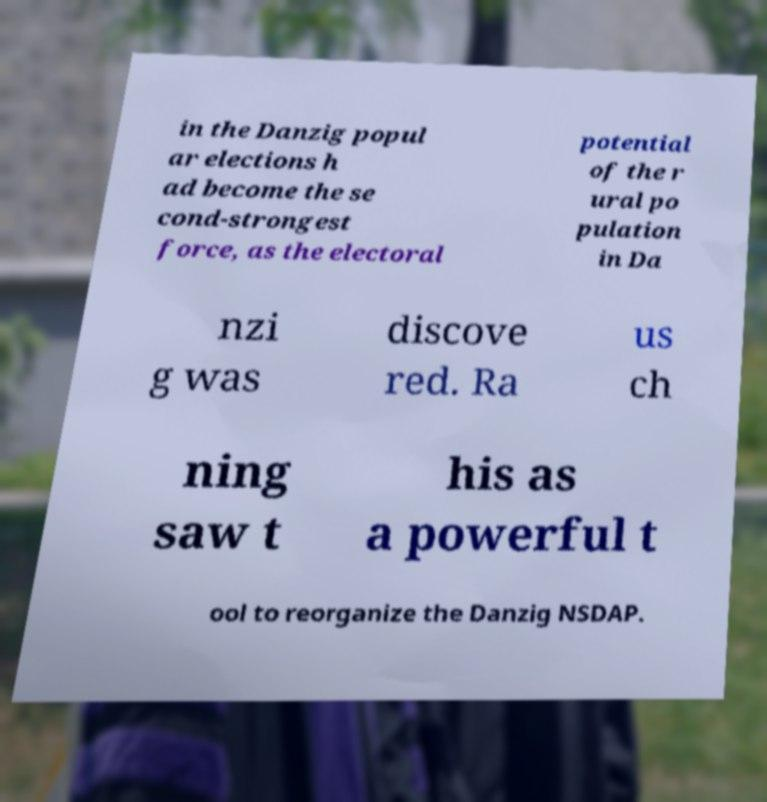Please read and relay the text visible in this image. What does it say? in the Danzig popul ar elections h ad become the se cond-strongest force, as the electoral potential of the r ural po pulation in Da nzi g was discove red. Ra us ch ning saw t his as a powerful t ool to reorganize the Danzig NSDAP. 